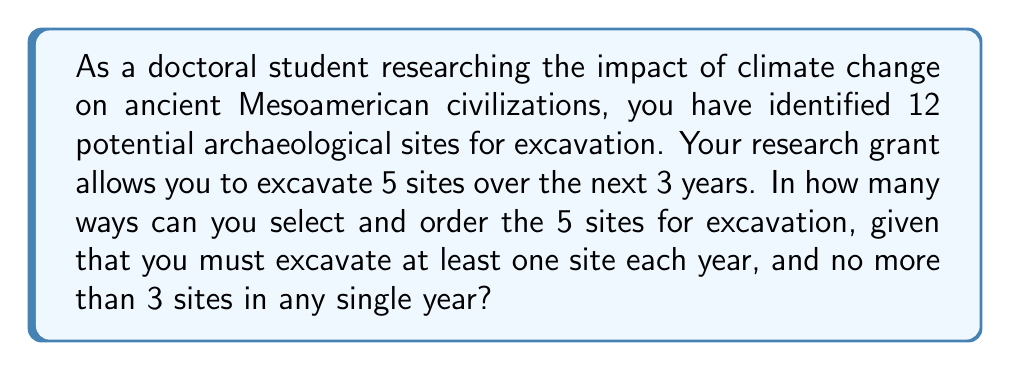Help me with this question. Let's approach this step-by-step:

1) First, we need to consider the possible distributions of 5 sites over 3 years, respecting the constraints:
   - At least one site each year
   - No more than 3 sites in any single year

   The possible distributions are:
   (3,1,1), (2,2,1), (2,1,2), (1,2,2), (1,3,1), (1,1,3)

2) Now, for each distribution, we need to calculate the number of ways to select and order the sites:

   a) For (3,1,1):
      - Choose 3 sites from 12: $\binom{12}{3}$
      - Arrange these 3: $3!$
      - Choose 1 from remaining 9: $\binom{9}{1}$
      - Choose 1 from remaining 8: $\binom{8}{1}$
      - Total: $\binom{12}{3} \cdot 3! \cdot \binom{9}{1} \cdot \binom{8}{1} \cdot 3!$
        (The final $3!$ is to arrange the years)

   b) For (2,2,1) and its permutations:
      - Choose 2 from 12: $\binom{12}{2}$
      - Choose 2 from remaining 10: $\binom{10}{2}$
      - Choose 1 from remaining 8: $\binom{8}{1}$
      - Total: $\binom{12}{2} \cdot \binom{10}{2} \cdot \binom{8}{1} \cdot 3!$
      - This needs to be multiplied by 3 for the three permutations

   c) For (1,3,1) and its permutation:
      - Choose 1 from 12: $\binom{12}{1}$
      - Choose 3 from remaining 11: $\binom{11}{3}$
      - Arrange these 3: $3!$
      - Choose 1 from remaining 8: $\binom{8}{1}$
      - Total: $\binom{12}{1} \cdot \binom{11}{3} \cdot 3! \cdot \binom{8}{1} \cdot 3!$
      - This needs to be multiplied by 2 for the two permutations

3) Sum up all these possibilities:

   $$\binom{12}{3} \cdot 3! \cdot \binom{9}{1} \cdot \binom{8}{1} \cdot 3! + $$
   $$3 \cdot \binom{12}{2} \cdot \binom{10}{2} \cdot \binom{8}{1} \cdot 3! + $$
   $$2 \cdot \binom{12}{1} \cdot \binom{11}{3} \cdot 3! \cdot \binom{8}{1} \cdot 3!$$

4) Calculate:
   $$(220 \cdot 6 \cdot 9 \cdot 8 \cdot 6) + (3 \cdot 66 \cdot 45 \cdot 8 \cdot 6) + (2 \cdot 12 \cdot 165 \cdot 6 \cdot 8 \cdot 6)$$
   $$= 570,240 + 427,680 + 1,140,480$$
   $$= 2,138,400$$
Answer: There are 2,138,400 ways to select and order 5 out of 12 archaeological sites for excavation over 3 years, given the specified constraints. 